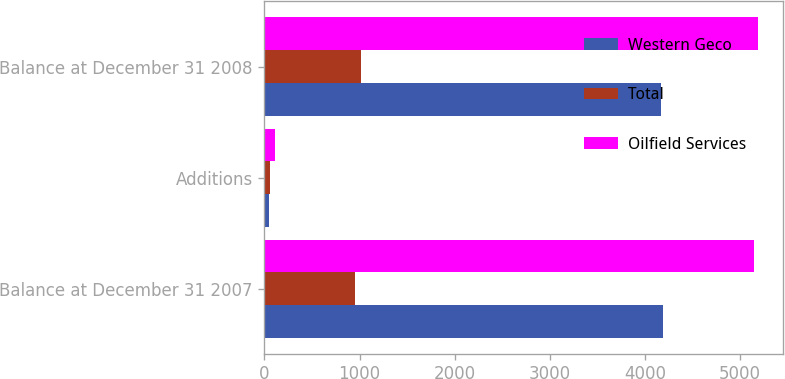<chart> <loc_0><loc_0><loc_500><loc_500><stacked_bar_chart><ecel><fcel>Balance at December 31 2007<fcel>Additions<fcel>Balance at December 31 2008<nl><fcel>Western Geco<fcel>4185<fcel>49<fcel>4174<nl><fcel>Total<fcel>957<fcel>58<fcel>1015<nl><fcel>Oilfield Services<fcel>5142<fcel>107<fcel>5189<nl></chart> 